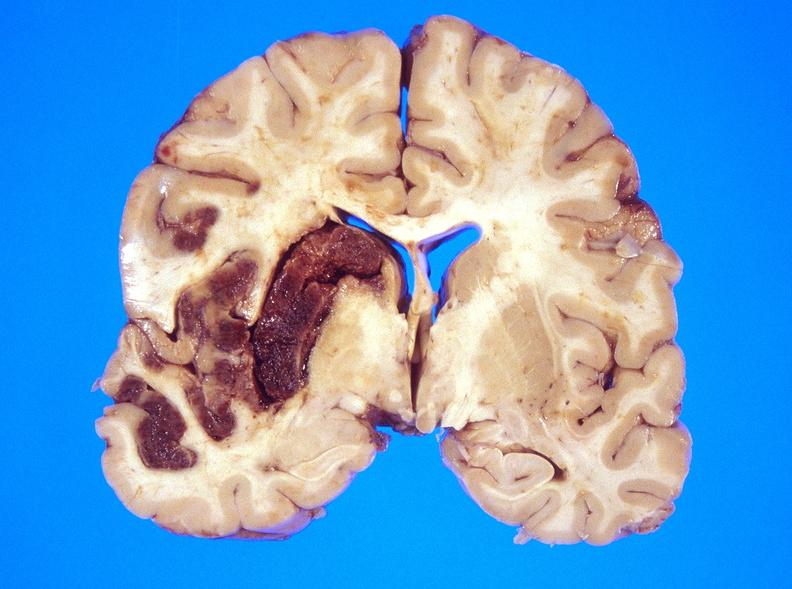does immunostain for growth hormone show hemorrhagic reperfusion infarct, middle cerebral artery l?
Answer the question using a single word or phrase. No 